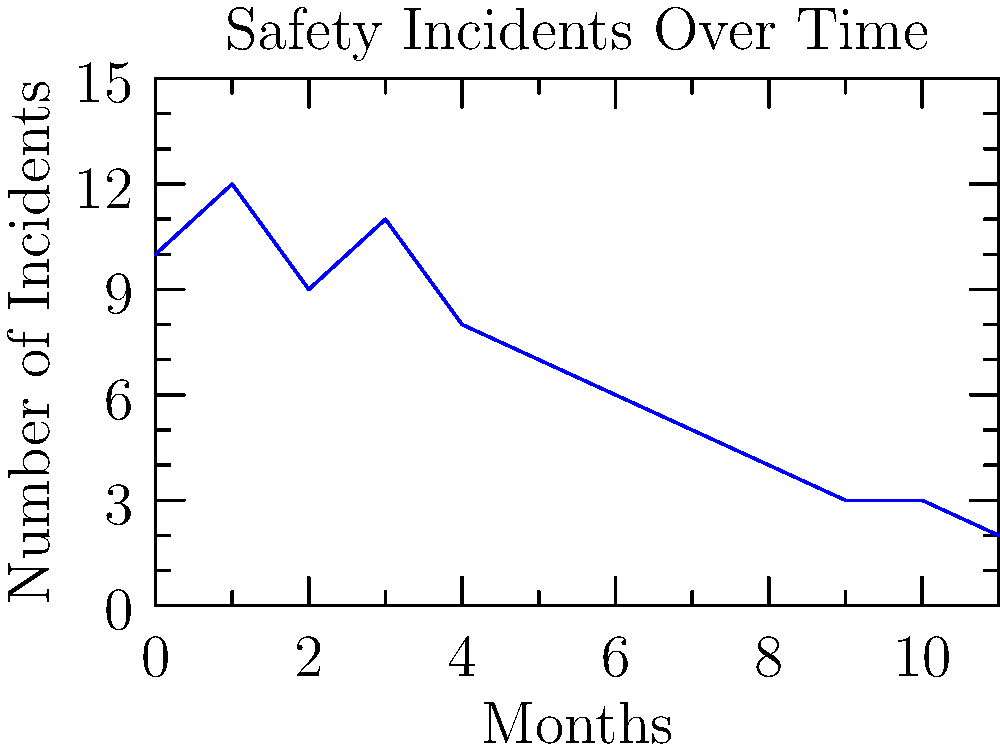As a risk manager, you are presented with the above graph showing the number of safety incidents in your manufacturing facility over the past year. What is the most likely explanation for the trend shown in the graph, and what action would you recommend based on this data? To interpret this graph and make a recommendation, let's follow these steps:

1. Observe the trend: The graph shows a clear downward trend in the number of safety incidents over time.

2. Quantify the change: The number of incidents decreased from about 10-12 in the first few months to 2-3 in the last few months, which is a significant reduction.

3. Consider possible explanations:
   a) Implementation of new safety measures
   b) Increased safety training and awareness
   c) Improved equipment maintenance
   d) Changes in reporting procedures

4. Most likely explanation: Given the consistent downward trend, the most likely explanation is the successful implementation of new safety measures and increased safety training.

5. Recommend action:
   a) Continue with the current safety program as it appears to be effective
   b) Analyze which specific measures contributed most to the reduction
   c) Share best practices across different areas of the facility
   d) Set new safety goals to maintain or further improve the trend

6. Conclusion: The most appropriate action would be to continue the current safety program while analyzing its components to identify the most effective measures for potential expansion or replication in other areas.
Answer: Continue current safety program; analyze effective measures for potential expansion. 